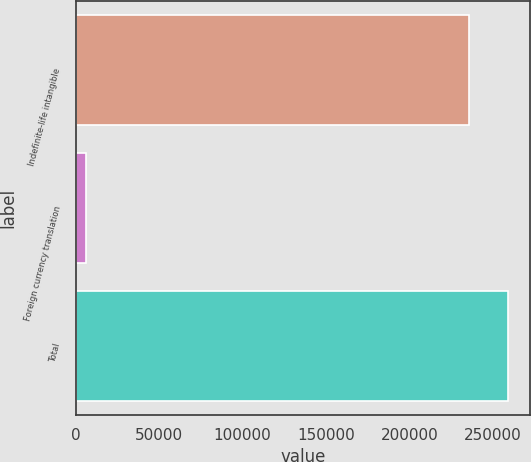Convert chart. <chart><loc_0><loc_0><loc_500><loc_500><bar_chart><fcel>Indefinite-life intangible<fcel>Foreign currency translation<fcel>Total<nl><fcel>235610<fcel>5953<fcel>259171<nl></chart> 